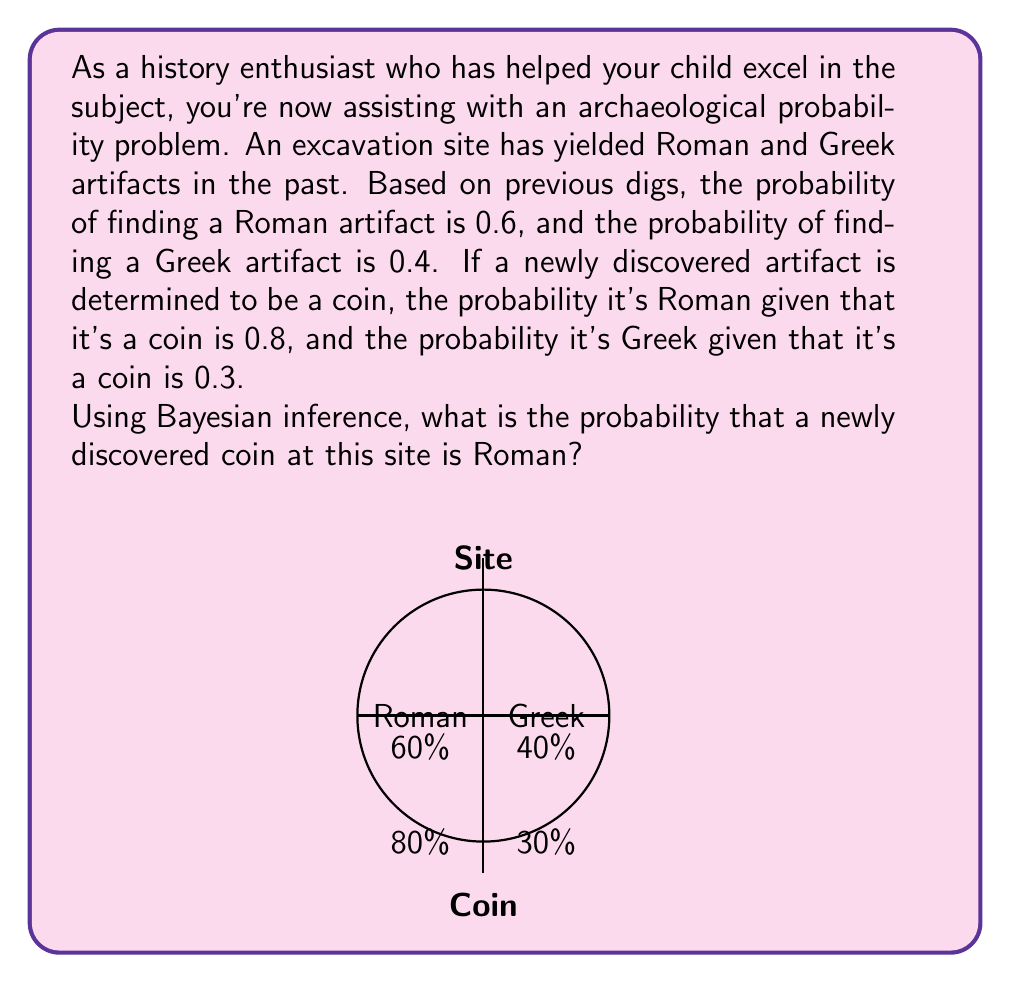Teach me how to tackle this problem. Let's approach this step-by-step using Bayes' theorem:

1) Define our events:
   R: The artifact is Roman
   C: The artifact is a coin

2) We're given:
   P(R) = 0.6 (prior probability of Roman artifact)
   P(C|R) = 0.8 (probability of coin given it's Roman)
   P(C|G) = 0.3 (probability of coin given it's Greek)

3) Bayes' theorem states:

   $$P(R|C) = \frac{P(C|R) \cdot P(R)}{P(C)}$$

4) We need to calculate P(C) using the law of total probability:

   $$P(C) = P(C|R) \cdot P(R) + P(C|G) \cdot P(G)$$

5) Calculate P(C):
   P(G) = 1 - P(R) = 0.4
   P(C) = 0.8 * 0.6 + 0.3 * 0.4 = 0.48 + 0.12 = 0.6

6) Now we can apply Bayes' theorem:

   $$P(R|C) = \frac{0.8 \cdot 0.6}{0.6} = \frac{0.48}{0.6} = 0.8$$

Therefore, the probability that a newly discovered coin at this site is Roman is 0.8 or 80%.
Answer: 0.8 